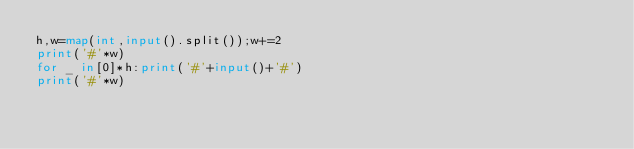<code> <loc_0><loc_0><loc_500><loc_500><_Python_>h,w=map(int,input().split());w+=2
print('#'*w)
for _ in[0]*h:print('#'+input()+'#')
print('#'*w)</code> 